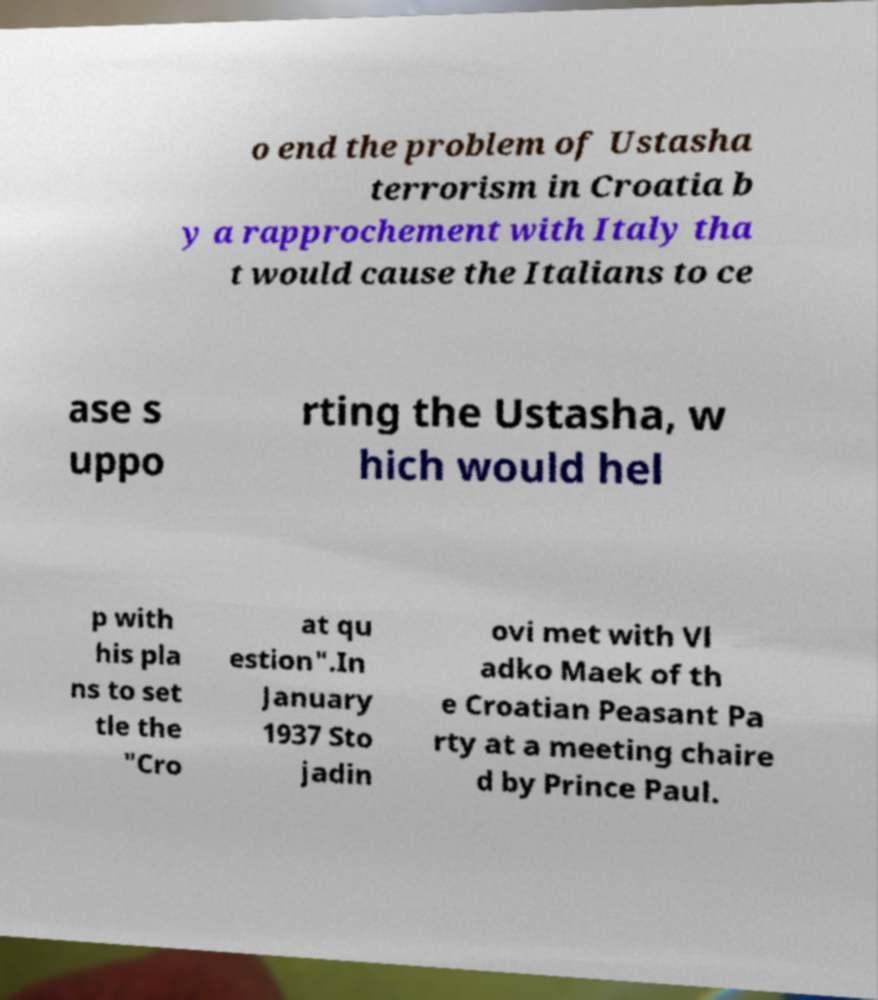I need the written content from this picture converted into text. Can you do that? o end the problem of Ustasha terrorism in Croatia b y a rapprochement with Italy tha t would cause the Italians to ce ase s uppo rting the Ustasha, w hich would hel p with his pla ns to set tle the "Cro at qu estion".In January 1937 Sto jadin ovi met with Vl adko Maek of th e Croatian Peasant Pa rty at a meeting chaire d by Prince Paul. 